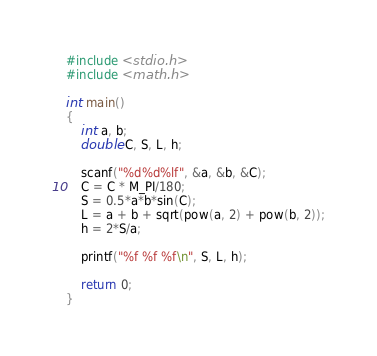Convert code to text. <code><loc_0><loc_0><loc_500><loc_500><_C_>#include <stdio.h>
#include <math.h>

int main()
{
    int a, b;
    double C, S, L, h;
    
    scanf("%d%d%lf", &a, &b, &C);
    C = C * M_PI/180;
    S = 0.5*a*b*sin(C);
    L = a + b + sqrt(pow(a, 2) + pow(b, 2));
    h = 2*S/a;
    
    printf("%f %f %f\n", S, L, h);
    
    return 0;
}</code> 